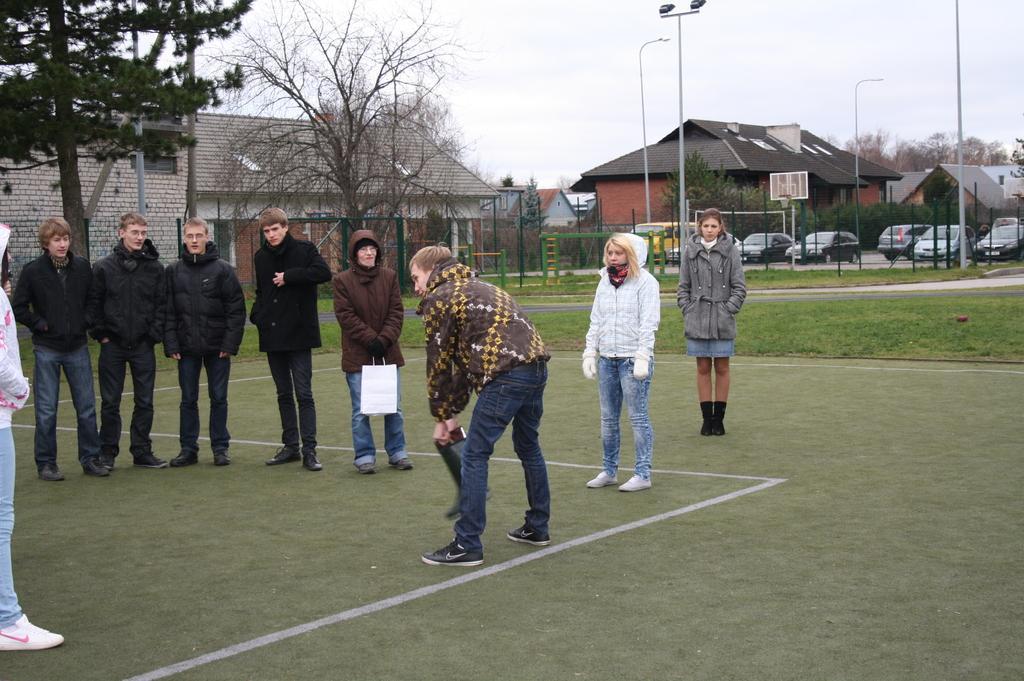In one or two sentences, can you explain what this image depicts? In this picture there are group of people standing and there is a person with brown and yellow jacket is standing and holding the object and there is a person with brown jacket is standing and holding the object. At the back there are buildings, trees, poles and there are vehicles and there is a fence. At the top there is sky. At the bottom there is grass. 